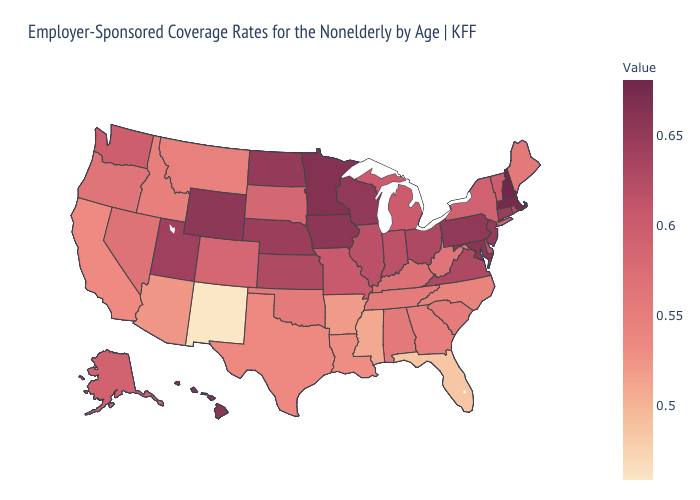Does the map have missing data?
Quick response, please. No. Among the states that border Wyoming , which have the highest value?
Short answer required. Nebraska. Which states hav the highest value in the Northeast?
Give a very brief answer. New Hampshire. Which states have the highest value in the USA?
Give a very brief answer. New Hampshire. Does the map have missing data?
Write a very short answer. No. Among the states that border Indiana , does Ohio have the highest value?
Be succinct. Yes. 